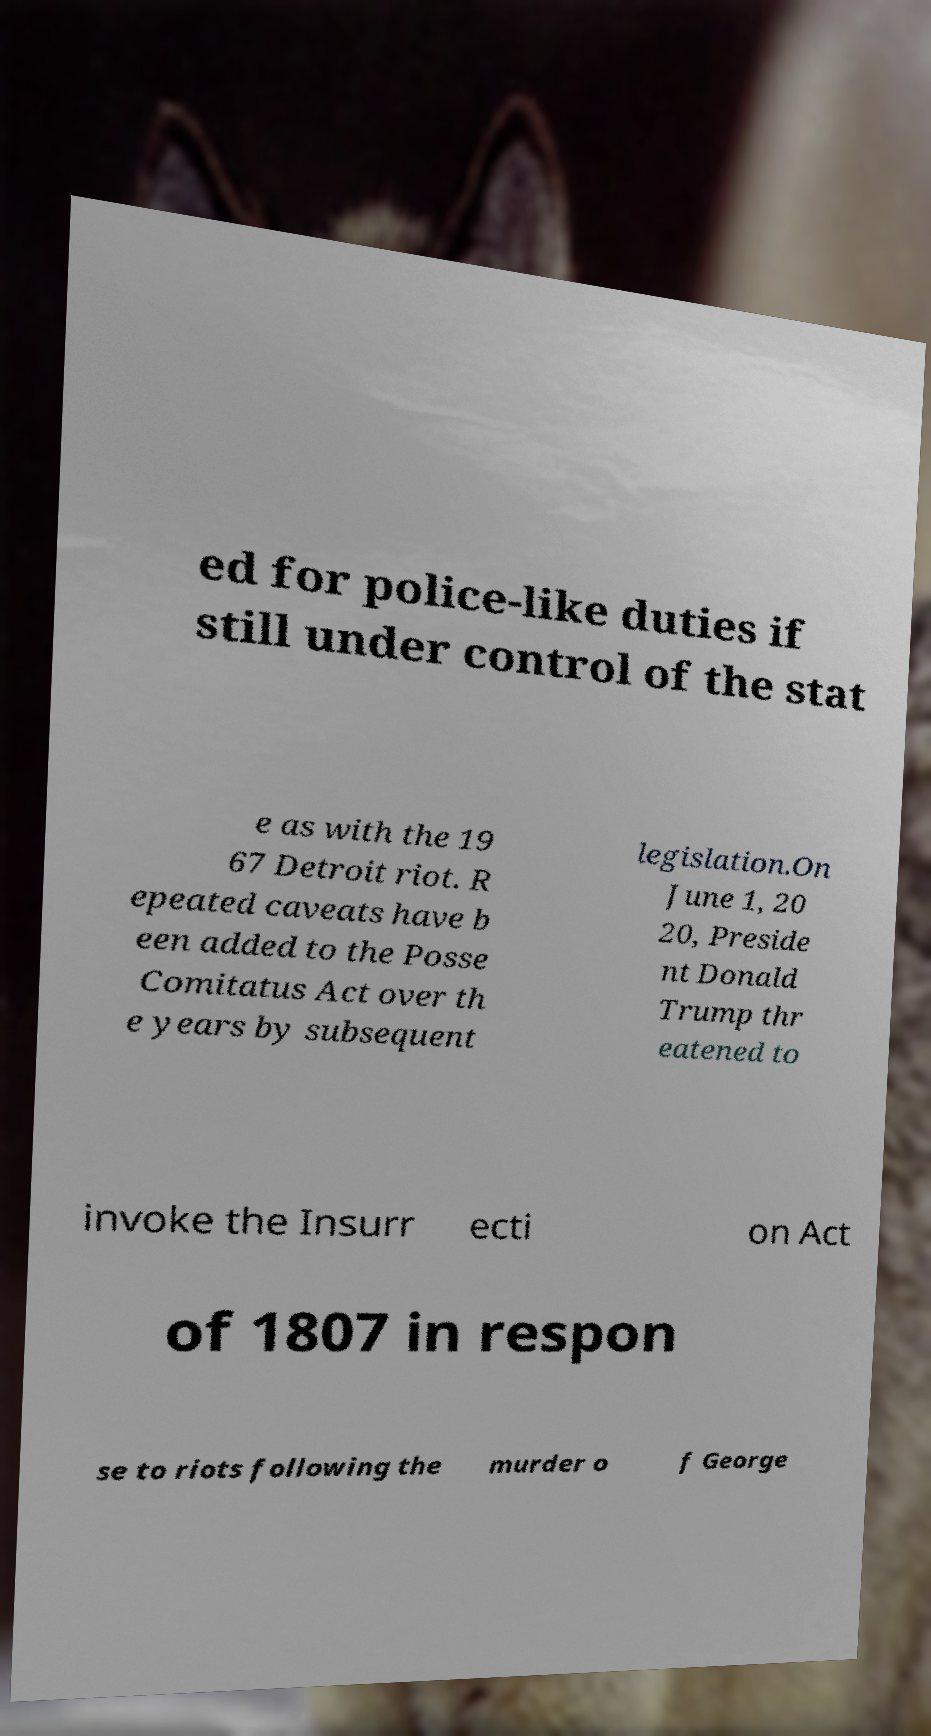Can you accurately transcribe the text from the provided image for me? ed for police-like duties if still under control of the stat e as with the 19 67 Detroit riot. R epeated caveats have b een added to the Posse Comitatus Act over th e years by subsequent legislation.On June 1, 20 20, Preside nt Donald Trump thr eatened to invoke the Insurr ecti on Act of 1807 in respon se to riots following the murder o f George 